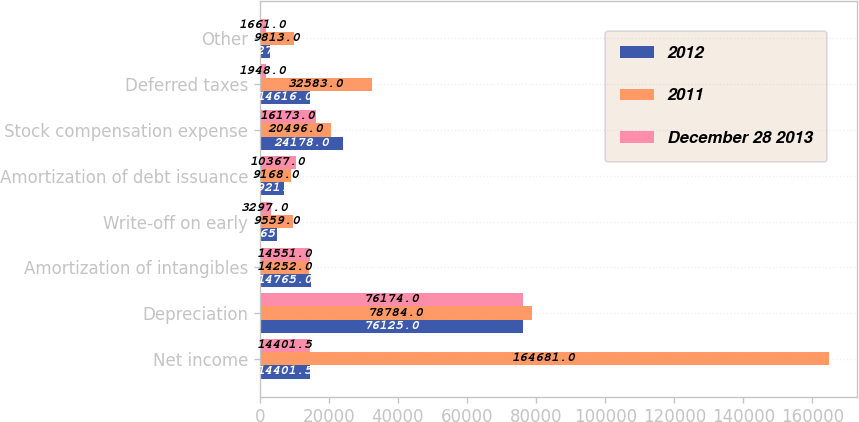Convert chart. <chart><loc_0><loc_0><loc_500><loc_500><stacked_bar_chart><ecel><fcel>Net income<fcel>Depreciation<fcel>Amortization of intangibles<fcel>Write-off on early<fcel>Amortization of debt issuance<fcel>Stock compensation expense<fcel>Deferred taxes<fcel>Other<nl><fcel>2012<fcel>14401.5<fcel>76125<fcel>14765<fcel>4865<fcel>6921<fcel>24178<fcel>14616<fcel>3027<nl><fcel>2011<fcel>164681<fcel>78784<fcel>14252<fcel>9559<fcel>9168<fcel>20496<fcel>32583<fcel>9813<nl><fcel>December 28 2013<fcel>14401.5<fcel>76174<fcel>14551<fcel>3297<fcel>10367<fcel>16173<fcel>1948<fcel>1661<nl></chart> 